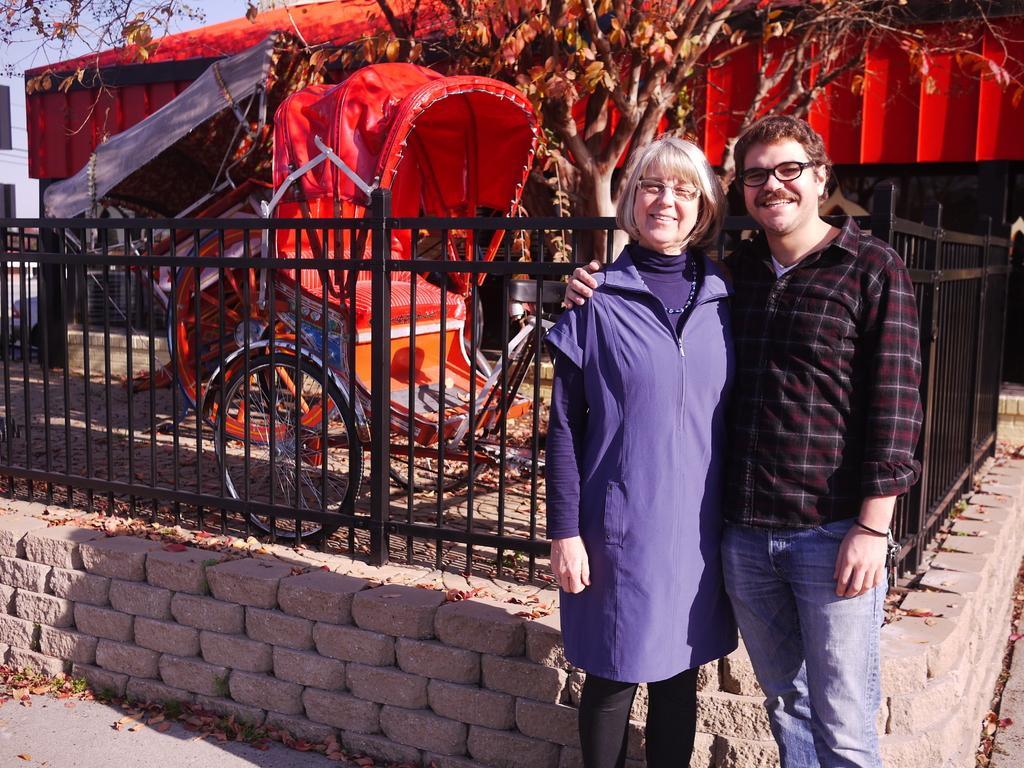Could you give a brief overview of what you see in this image? On the right side of the image we can see two persons are standing and they are smiling, which we can see on their faces. And they are wearing glasses and they are in different costumes. In the background, we can see the sky, one building, tent, one colorful rickshaw, tree, vehicle, dry leaves, fences and a few other objects. 